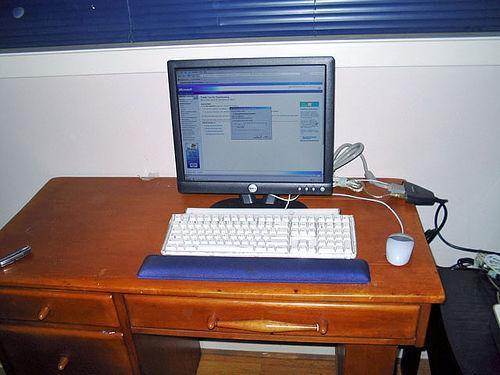How many desk drawers are visible?
Give a very brief answer. 3. How many computers are pictured?
Give a very brief answer. 1. How many drawers have a long handle in the image?
Give a very brief answer. 1. 